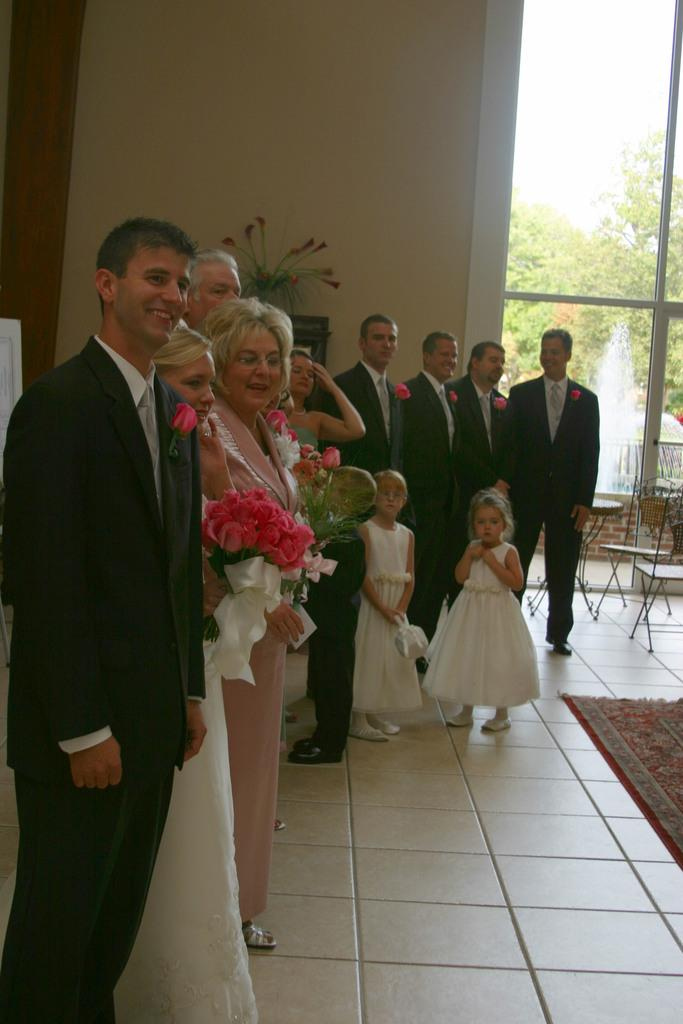What can be seen in the foreground of the image? There are people standing in the foreground of the image. What are some of the people holding? Some of the people are holding flowers. What objects are present in the image besides the people? There are chairs in the image. What can be seen in the background of the image? There are trees, a plant, windows, and the sky visible in the background. What type of beast can be seen playing the drum in the image? There is no beast or drum present in the image. 